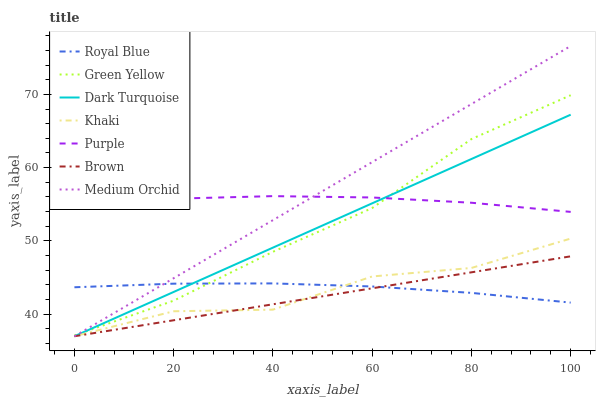Does Brown have the minimum area under the curve?
Answer yes or no. Yes. Does Medium Orchid have the maximum area under the curve?
Answer yes or no. Yes. Does Khaki have the minimum area under the curve?
Answer yes or no. No. Does Khaki have the maximum area under the curve?
Answer yes or no. No. Is Medium Orchid the smoothest?
Answer yes or no. Yes. Is Khaki the roughest?
Answer yes or no. Yes. Is Purple the smoothest?
Answer yes or no. No. Is Purple the roughest?
Answer yes or no. No. Does Brown have the lowest value?
Answer yes or no. Yes. Does Purple have the lowest value?
Answer yes or no. No. Does Medium Orchid have the highest value?
Answer yes or no. Yes. Does Khaki have the highest value?
Answer yes or no. No. Is Royal Blue less than Purple?
Answer yes or no. Yes. Is Purple greater than Royal Blue?
Answer yes or no. Yes. Does Dark Turquoise intersect Brown?
Answer yes or no. Yes. Is Dark Turquoise less than Brown?
Answer yes or no. No. Is Dark Turquoise greater than Brown?
Answer yes or no. No. Does Royal Blue intersect Purple?
Answer yes or no. No. 